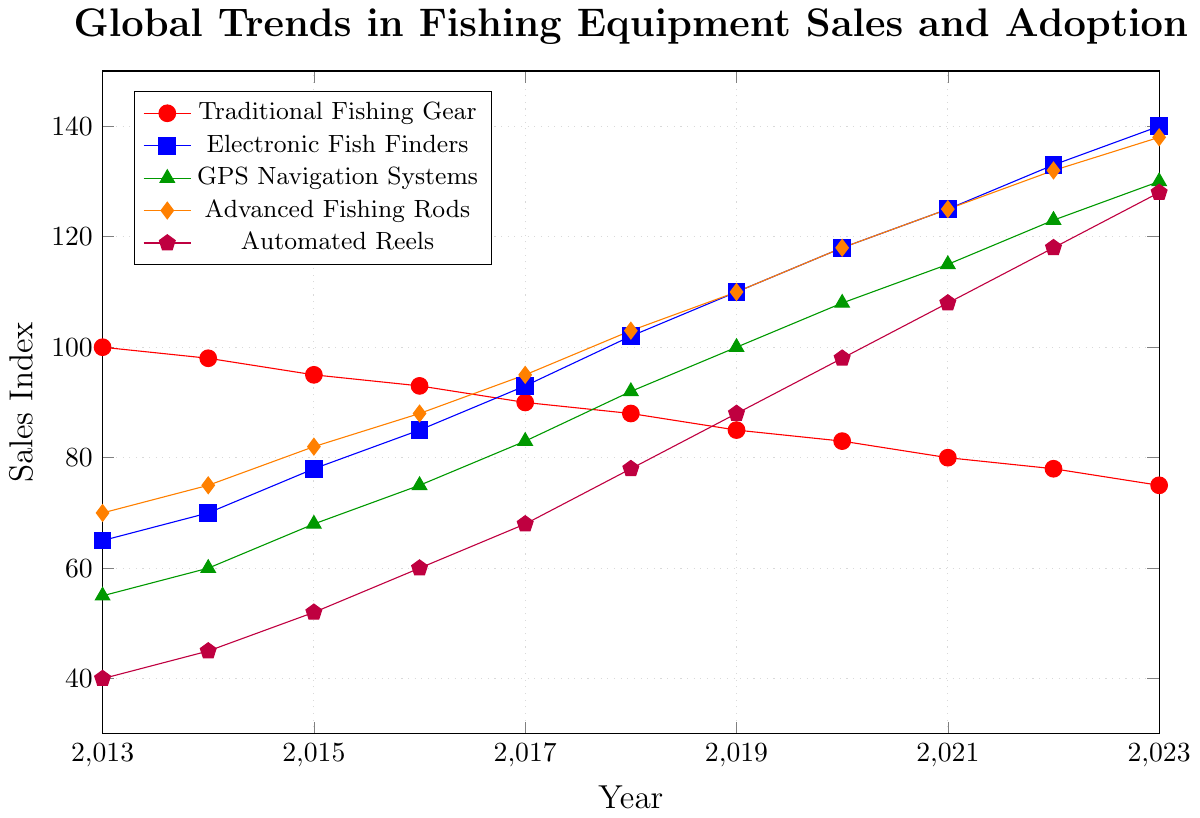Which fishing equipment had the highest sales index in 2023? To determine the fishing equipment with the highest sales index in 2023, we need to compare the sales index values for all the equipment types in that year. The equipment types and their respective sales indices in 2023 are:
- Traditional Fishing Gear: 75
- Electronic Fish Finders: 140
- GPS Navigation Systems: 130
- Advanced Fishing Rods: 138
- Automated Reels: 128
From these values, we can see that Electronic Fish Finders had the highest sales index.
Answer: Electronic Fish Finders Which fishing equipment showed a consistent increase in sales index from 2013 to 2023? To find the fishing equipment that showed a consistent increase in sales index, we must identify the equipment whose sales index value increased every consecutive year from 2013 to 2023. From the data:
- Traditional Fishing Gear: decreased
- Electronic Fish Finders: increased
- GPS Navigation Systems: increased
- Advanced Fishing Rods: increased
- Automated Reels: increased
All equipment except for Traditional Fishing Gear exhibited an upward trend.
Answer: Electronic Fish Finders, GPS Navigation Systems, Advanced Fishing Rods, Automated Reels By how much did the sales index of Advanced Fishing Rods increase from 2013 to 2023? To calculate the increase in the sales index of Advanced Fishing Rods from 2013 to 2023, subtract the 2013 value from the 2023 value. The value in 2013 was 70, and the value in 2023 was 138. The difference is 138 - 70.
Answer: 68 What was the average sales index of Automated Reels from 2018 to 2023? To find the average sales index of Automated Reels from 2018 to 2023, we sum the sales indices for these years and divide by the number of years. The values are:
2018: 78, 2019: 88, 2020: 98, 2021: 108, 2022: 118, 2023: 128. 
Summing these values: 78 + 88 + 98 + 108 + 118 + 128 = 618
Dividing by the number of years: 618 / 6 = 103
Answer: 103 Which piece of equipment had the most significant percentage increase in its sales index from 2013 to 2023? To find the piece of equipment with the most significant percentage increase, we calculate the percentage increase for each piece by using the formula ((value in 2023 - value in 2013) / value in 2013) * 100. The calculations are:
- Traditional Fishing Gear: ((75 - 100) / 100) * 100 = -25%
- Electronic Fish Finders: ((140 - 65) / 65) * 100 = 115.38%
- GPS Navigation Systems: ((130 - 55) / 55) * 100 = 136.36%
- Advanced Fishing Rods: ((138 - 70) / 70) * 100 = 97.14%
- Automated Reels: ((128 - 40) / 40) * 100 = 220%
Automated Reels had the most significant percentage increase.
Answer: Automated Reels In what year did GPS Navigation Systems surpass Traditional Fishing Gear in sales index? To determine when GPS Navigation Systems surpassed Traditional Fishing Gear in sales index, we compare the sales indices for each year until we find when the former first exceeded the latter. 
- 2013: 55 < 100
- 2014: 60 < 98
- 2015: 68 < 95
- 2016: 75 < 93
- 2017: 83 < 90
- 2018: 92 > 88
In 2018, GPS Navigation Systems surpassed Traditional Fishing Gear.
Answer: 2018 